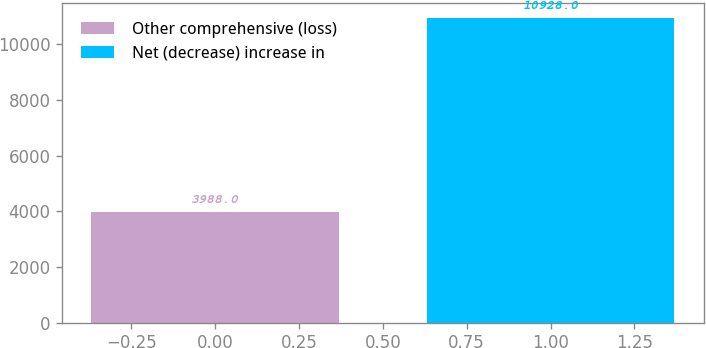Convert chart to OTSL. <chart><loc_0><loc_0><loc_500><loc_500><bar_chart><fcel>Other comprehensive (loss)<fcel>Net (decrease) increase in<nl><fcel>3988<fcel>10928<nl></chart> 